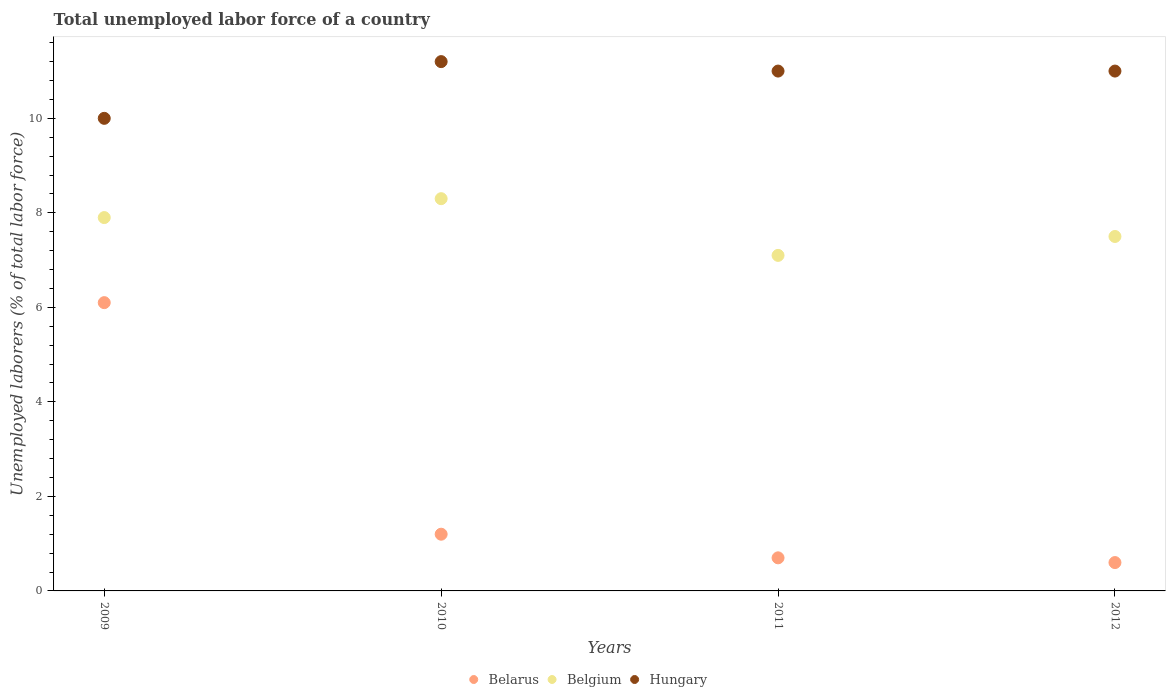Is the number of dotlines equal to the number of legend labels?
Give a very brief answer. Yes. What is the total unemployed labor force in Belgium in 2012?
Keep it short and to the point. 7.5. Across all years, what is the maximum total unemployed labor force in Belarus?
Make the answer very short. 6.1. In which year was the total unemployed labor force in Belgium maximum?
Ensure brevity in your answer.  2010. In which year was the total unemployed labor force in Belarus minimum?
Your response must be concise. 2012. What is the total total unemployed labor force in Belgium in the graph?
Ensure brevity in your answer.  30.8. What is the difference between the total unemployed labor force in Belgium in 2009 and that in 2012?
Your response must be concise. 0.4. What is the difference between the total unemployed labor force in Belgium in 2009 and the total unemployed labor force in Hungary in 2010?
Provide a short and direct response. -3.3. What is the average total unemployed labor force in Belarus per year?
Keep it short and to the point. 2.15. In the year 2010, what is the difference between the total unemployed labor force in Hungary and total unemployed labor force in Belgium?
Offer a terse response. 2.9. What is the ratio of the total unemployed labor force in Belgium in 2011 to that in 2012?
Provide a succinct answer. 0.95. Is the total unemployed labor force in Belarus in 2010 less than that in 2011?
Provide a short and direct response. No. What is the difference between the highest and the second highest total unemployed labor force in Hungary?
Offer a very short reply. 0.2. What is the difference between the highest and the lowest total unemployed labor force in Belarus?
Keep it short and to the point. 5.5. In how many years, is the total unemployed labor force in Belarus greater than the average total unemployed labor force in Belarus taken over all years?
Your answer should be compact. 1. Is the sum of the total unemployed labor force in Hungary in 2011 and 2012 greater than the maximum total unemployed labor force in Belgium across all years?
Provide a short and direct response. Yes. Is the total unemployed labor force in Belarus strictly less than the total unemployed labor force in Hungary over the years?
Make the answer very short. Yes. What is the difference between two consecutive major ticks on the Y-axis?
Offer a very short reply. 2. Does the graph contain grids?
Offer a very short reply. No. How many legend labels are there?
Keep it short and to the point. 3. What is the title of the graph?
Your answer should be very brief. Total unemployed labor force of a country. Does "Kenya" appear as one of the legend labels in the graph?
Your answer should be very brief. No. What is the label or title of the X-axis?
Your answer should be very brief. Years. What is the label or title of the Y-axis?
Offer a very short reply. Unemployed laborers (% of total labor force). What is the Unemployed laborers (% of total labor force) of Belarus in 2009?
Make the answer very short. 6.1. What is the Unemployed laborers (% of total labor force) of Belgium in 2009?
Offer a terse response. 7.9. What is the Unemployed laborers (% of total labor force) in Hungary in 2009?
Ensure brevity in your answer.  10. What is the Unemployed laborers (% of total labor force) of Belarus in 2010?
Offer a terse response. 1.2. What is the Unemployed laborers (% of total labor force) of Belgium in 2010?
Provide a short and direct response. 8.3. What is the Unemployed laborers (% of total labor force) of Hungary in 2010?
Provide a succinct answer. 11.2. What is the Unemployed laborers (% of total labor force) of Belarus in 2011?
Your answer should be very brief. 0.7. What is the Unemployed laborers (% of total labor force) in Belgium in 2011?
Ensure brevity in your answer.  7.1. What is the Unemployed laborers (% of total labor force) of Belarus in 2012?
Offer a terse response. 0.6. Across all years, what is the maximum Unemployed laborers (% of total labor force) of Belarus?
Keep it short and to the point. 6.1. Across all years, what is the maximum Unemployed laborers (% of total labor force) of Belgium?
Your answer should be compact. 8.3. Across all years, what is the maximum Unemployed laborers (% of total labor force) of Hungary?
Your answer should be very brief. 11.2. Across all years, what is the minimum Unemployed laborers (% of total labor force) in Belarus?
Offer a terse response. 0.6. Across all years, what is the minimum Unemployed laborers (% of total labor force) in Belgium?
Provide a succinct answer. 7.1. Across all years, what is the minimum Unemployed laborers (% of total labor force) in Hungary?
Offer a terse response. 10. What is the total Unemployed laborers (% of total labor force) in Belarus in the graph?
Offer a terse response. 8.6. What is the total Unemployed laborers (% of total labor force) in Belgium in the graph?
Provide a short and direct response. 30.8. What is the total Unemployed laborers (% of total labor force) in Hungary in the graph?
Make the answer very short. 43.2. What is the difference between the Unemployed laborers (% of total labor force) in Belgium in 2009 and that in 2010?
Your answer should be compact. -0.4. What is the difference between the Unemployed laborers (% of total labor force) of Hungary in 2009 and that in 2010?
Provide a short and direct response. -1.2. What is the difference between the Unemployed laborers (% of total labor force) of Belgium in 2009 and that in 2011?
Offer a very short reply. 0.8. What is the difference between the Unemployed laborers (% of total labor force) in Belarus in 2010 and that in 2011?
Offer a terse response. 0.5. What is the difference between the Unemployed laborers (% of total labor force) in Hungary in 2010 and that in 2011?
Make the answer very short. 0.2. What is the difference between the Unemployed laborers (% of total labor force) of Belarus in 2011 and that in 2012?
Ensure brevity in your answer.  0.1. What is the difference between the Unemployed laborers (% of total labor force) in Hungary in 2011 and that in 2012?
Make the answer very short. 0. What is the difference between the Unemployed laborers (% of total labor force) in Belgium in 2009 and the Unemployed laborers (% of total labor force) in Hungary in 2010?
Provide a short and direct response. -3.3. What is the difference between the Unemployed laborers (% of total labor force) of Belarus in 2009 and the Unemployed laborers (% of total labor force) of Belgium in 2011?
Provide a succinct answer. -1. What is the difference between the Unemployed laborers (% of total labor force) of Belarus in 2009 and the Unemployed laborers (% of total labor force) of Hungary in 2011?
Keep it short and to the point. -4.9. What is the difference between the Unemployed laborers (% of total labor force) in Belarus in 2009 and the Unemployed laborers (% of total labor force) in Hungary in 2012?
Offer a terse response. -4.9. What is the difference between the Unemployed laborers (% of total labor force) of Belgium in 2009 and the Unemployed laborers (% of total labor force) of Hungary in 2012?
Offer a very short reply. -3.1. What is the difference between the Unemployed laborers (% of total labor force) of Belarus in 2010 and the Unemployed laborers (% of total labor force) of Hungary in 2011?
Keep it short and to the point. -9.8. What is the difference between the Unemployed laborers (% of total labor force) of Belgium in 2010 and the Unemployed laborers (% of total labor force) of Hungary in 2011?
Your response must be concise. -2.7. What is the difference between the Unemployed laborers (% of total labor force) of Belarus in 2010 and the Unemployed laborers (% of total labor force) of Belgium in 2012?
Your answer should be very brief. -6.3. What is the difference between the Unemployed laborers (% of total labor force) in Belarus in 2010 and the Unemployed laborers (% of total labor force) in Hungary in 2012?
Your response must be concise. -9.8. What is the difference between the Unemployed laborers (% of total labor force) in Belgium in 2010 and the Unemployed laborers (% of total labor force) in Hungary in 2012?
Your response must be concise. -2.7. What is the difference between the Unemployed laborers (% of total labor force) in Belarus in 2011 and the Unemployed laborers (% of total labor force) in Belgium in 2012?
Your response must be concise. -6.8. What is the difference between the Unemployed laborers (% of total labor force) in Belarus in 2011 and the Unemployed laborers (% of total labor force) in Hungary in 2012?
Your answer should be compact. -10.3. What is the average Unemployed laborers (% of total labor force) in Belarus per year?
Give a very brief answer. 2.15. What is the average Unemployed laborers (% of total labor force) in Belgium per year?
Ensure brevity in your answer.  7.7. In the year 2009, what is the difference between the Unemployed laborers (% of total labor force) in Belgium and Unemployed laborers (% of total labor force) in Hungary?
Give a very brief answer. -2.1. In the year 2010, what is the difference between the Unemployed laborers (% of total labor force) in Belarus and Unemployed laborers (% of total labor force) in Belgium?
Provide a succinct answer. -7.1. In the year 2010, what is the difference between the Unemployed laborers (% of total labor force) of Belarus and Unemployed laborers (% of total labor force) of Hungary?
Ensure brevity in your answer.  -10. In the year 2010, what is the difference between the Unemployed laborers (% of total labor force) of Belgium and Unemployed laborers (% of total labor force) of Hungary?
Your response must be concise. -2.9. In the year 2012, what is the difference between the Unemployed laborers (% of total labor force) of Belarus and Unemployed laborers (% of total labor force) of Belgium?
Give a very brief answer. -6.9. In the year 2012, what is the difference between the Unemployed laborers (% of total labor force) in Belgium and Unemployed laborers (% of total labor force) in Hungary?
Your answer should be very brief. -3.5. What is the ratio of the Unemployed laborers (% of total labor force) in Belarus in 2009 to that in 2010?
Your response must be concise. 5.08. What is the ratio of the Unemployed laborers (% of total labor force) in Belgium in 2009 to that in 2010?
Keep it short and to the point. 0.95. What is the ratio of the Unemployed laborers (% of total labor force) of Hungary in 2009 to that in 2010?
Provide a succinct answer. 0.89. What is the ratio of the Unemployed laborers (% of total labor force) in Belarus in 2009 to that in 2011?
Your answer should be compact. 8.71. What is the ratio of the Unemployed laborers (% of total labor force) in Belgium in 2009 to that in 2011?
Your response must be concise. 1.11. What is the ratio of the Unemployed laborers (% of total labor force) of Belarus in 2009 to that in 2012?
Ensure brevity in your answer.  10.17. What is the ratio of the Unemployed laborers (% of total labor force) of Belgium in 2009 to that in 2012?
Provide a short and direct response. 1.05. What is the ratio of the Unemployed laborers (% of total labor force) in Belarus in 2010 to that in 2011?
Ensure brevity in your answer.  1.71. What is the ratio of the Unemployed laborers (% of total labor force) in Belgium in 2010 to that in 2011?
Your answer should be compact. 1.17. What is the ratio of the Unemployed laborers (% of total labor force) of Hungary in 2010 to that in 2011?
Make the answer very short. 1.02. What is the ratio of the Unemployed laborers (% of total labor force) of Belgium in 2010 to that in 2012?
Make the answer very short. 1.11. What is the ratio of the Unemployed laborers (% of total labor force) of Hungary in 2010 to that in 2012?
Ensure brevity in your answer.  1.02. What is the ratio of the Unemployed laborers (% of total labor force) of Belarus in 2011 to that in 2012?
Provide a short and direct response. 1.17. What is the ratio of the Unemployed laborers (% of total labor force) of Belgium in 2011 to that in 2012?
Your response must be concise. 0.95. What is the difference between the highest and the second highest Unemployed laborers (% of total labor force) of Belarus?
Keep it short and to the point. 4.9. What is the difference between the highest and the second highest Unemployed laborers (% of total labor force) in Hungary?
Your answer should be very brief. 0.2. What is the difference between the highest and the lowest Unemployed laborers (% of total labor force) in Belarus?
Make the answer very short. 5.5. What is the difference between the highest and the lowest Unemployed laborers (% of total labor force) in Belgium?
Your response must be concise. 1.2. 